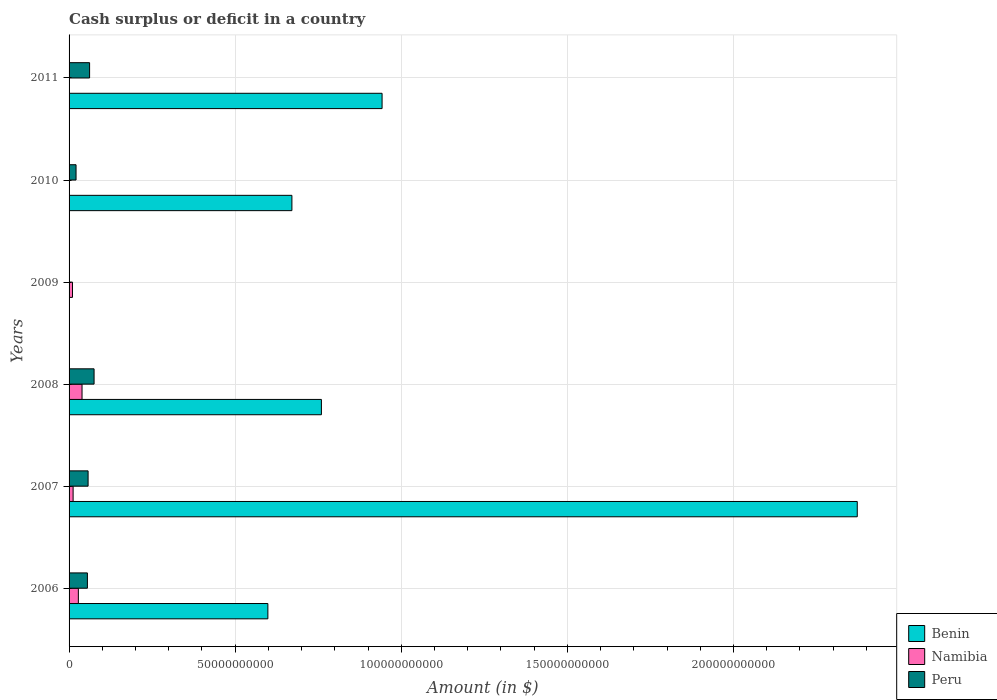Are the number of bars on each tick of the Y-axis equal?
Provide a succinct answer. No. In how many cases, is the number of bars for a given year not equal to the number of legend labels?
Offer a very short reply. 3. What is the amount of cash surplus or deficit in Benin in 2008?
Give a very brief answer. 7.60e+1. Across all years, what is the maximum amount of cash surplus or deficit in Peru?
Your answer should be compact. 7.53e+09. In which year was the amount of cash surplus or deficit in Benin maximum?
Give a very brief answer. 2007. What is the total amount of cash surplus or deficit in Namibia in the graph?
Keep it short and to the point. 8.94e+09. What is the difference between the amount of cash surplus or deficit in Peru in 2006 and that in 2007?
Offer a very short reply. -2.06e+08. What is the difference between the amount of cash surplus or deficit in Benin in 2009 and the amount of cash surplus or deficit in Peru in 2008?
Provide a short and direct response. -7.53e+09. What is the average amount of cash surplus or deficit in Namibia per year?
Make the answer very short. 1.49e+09. In the year 2006, what is the difference between the amount of cash surplus or deficit in Namibia and amount of cash surplus or deficit in Peru?
Your answer should be compact. -2.73e+09. In how many years, is the amount of cash surplus or deficit in Namibia greater than 40000000000 $?
Your answer should be very brief. 0. What is the ratio of the amount of cash surplus or deficit in Benin in 2007 to that in 2011?
Keep it short and to the point. 2.52. Is the amount of cash surplus or deficit in Peru in 2010 less than that in 2011?
Keep it short and to the point. Yes. What is the difference between the highest and the second highest amount of cash surplus or deficit in Benin?
Give a very brief answer. 1.43e+11. What is the difference between the highest and the lowest amount of cash surplus or deficit in Namibia?
Ensure brevity in your answer.  3.90e+09. How many bars are there?
Give a very brief answer. 14. Are all the bars in the graph horizontal?
Offer a terse response. Yes. How many years are there in the graph?
Your answer should be very brief. 6. Are the values on the major ticks of X-axis written in scientific E-notation?
Make the answer very short. No. Does the graph contain any zero values?
Your answer should be compact. Yes. What is the title of the graph?
Your answer should be very brief. Cash surplus or deficit in a country. Does "Pakistan" appear as one of the legend labels in the graph?
Offer a very short reply. No. What is the label or title of the X-axis?
Your answer should be very brief. Amount (in $). What is the Amount (in $) in Benin in 2006?
Keep it short and to the point. 5.98e+1. What is the Amount (in $) in Namibia in 2006?
Ensure brevity in your answer.  2.79e+09. What is the Amount (in $) of Peru in 2006?
Offer a very short reply. 5.52e+09. What is the Amount (in $) in Benin in 2007?
Provide a short and direct response. 2.37e+11. What is the Amount (in $) of Namibia in 2007?
Keep it short and to the point. 1.22e+09. What is the Amount (in $) of Peru in 2007?
Offer a very short reply. 5.73e+09. What is the Amount (in $) of Benin in 2008?
Your answer should be compact. 7.60e+1. What is the Amount (in $) in Namibia in 2008?
Keep it short and to the point. 3.90e+09. What is the Amount (in $) of Peru in 2008?
Provide a short and direct response. 7.53e+09. What is the Amount (in $) in Benin in 2009?
Your answer should be very brief. 0. What is the Amount (in $) of Namibia in 2009?
Ensure brevity in your answer.  1.03e+09. What is the Amount (in $) of Benin in 2010?
Your answer should be compact. 6.71e+1. What is the Amount (in $) in Namibia in 2010?
Ensure brevity in your answer.  0. What is the Amount (in $) of Peru in 2010?
Keep it short and to the point. 2.10e+09. What is the Amount (in $) of Benin in 2011?
Your answer should be compact. 9.42e+1. What is the Amount (in $) of Namibia in 2011?
Provide a short and direct response. 0. What is the Amount (in $) in Peru in 2011?
Offer a very short reply. 6.18e+09. Across all years, what is the maximum Amount (in $) of Benin?
Make the answer very short. 2.37e+11. Across all years, what is the maximum Amount (in $) of Namibia?
Your response must be concise. 3.90e+09. Across all years, what is the maximum Amount (in $) of Peru?
Keep it short and to the point. 7.53e+09. Across all years, what is the minimum Amount (in $) of Benin?
Keep it short and to the point. 0. Across all years, what is the minimum Amount (in $) of Peru?
Give a very brief answer. 0. What is the total Amount (in $) in Benin in the graph?
Offer a very short reply. 5.34e+11. What is the total Amount (in $) of Namibia in the graph?
Make the answer very short. 8.94e+09. What is the total Amount (in $) in Peru in the graph?
Your answer should be very brief. 2.71e+1. What is the difference between the Amount (in $) of Benin in 2006 and that in 2007?
Provide a succinct answer. -1.77e+11. What is the difference between the Amount (in $) of Namibia in 2006 and that in 2007?
Make the answer very short. 1.58e+09. What is the difference between the Amount (in $) of Peru in 2006 and that in 2007?
Ensure brevity in your answer.  -2.06e+08. What is the difference between the Amount (in $) in Benin in 2006 and that in 2008?
Provide a succinct answer. -1.61e+1. What is the difference between the Amount (in $) in Namibia in 2006 and that in 2008?
Keep it short and to the point. -1.11e+09. What is the difference between the Amount (in $) of Peru in 2006 and that in 2008?
Ensure brevity in your answer.  -2.01e+09. What is the difference between the Amount (in $) in Namibia in 2006 and that in 2009?
Give a very brief answer. 1.77e+09. What is the difference between the Amount (in $) of Benin in 2006 and that in 2010?
Ensure brevity in your answer.  -7.23e+09. What is the difference between the Amount (in $) in Peru in 2006 and that in 2010?
Offer a terse response. 3.42e+09. What is the difference between the Amount (in $) of Benin in 2006 and that in 2011?
Provide a short and direct response. -3.44e+1. What is the difference between the Amount (in $) of Peru in 2006 and that in 2011?
Provide a succinct answer. -6.57e+08. What is the difference between the Amount (in $) of Benin in 2007 and that in 2008?
Make the answer very short. 1.61e+11. What is the difference between the Amount (in $) of Namibia in 2007 and that in 2008?
Offer a very short reply. -2.69e+09. What is the difference between the Amount (in $) of Peru in 2007 and that in 2008?
Keep it short and to the point. -1.80e+09. What is the difference between the Amount (in $) in Namibia in 2007 and that in 2009?
Ensure brevity in your answer.  1.88e+08. What is the difference between the Amount (in $) of Benin in 2007 and that in 2010?
Give a very brief answer. 1.70e+11. What is the difference between the Amount (in $) in Peru in 2007 and that in 2010?
Provide a short and direct response. 3.63e+09. What is the difference between the Amount (in $) of Benin in 2007 and that in 2011?
Your answer should be compact. 1.43e+11. What is the difference between the Amount (in $) in Peru in 2007 and that in 2011?
Provide a succinct answer. -4.52e+08. What is the difference between the Amount (in $) in Namibia in 2008 and that in 2009?
Provide a succinct answer. 2.87e+09. What is the difference between the Amount (in $) of Benin in 2008 and that in 2010?
Offer a terse response. 8.88e+09. What is the difference between the Amount (in $) of Peru in 2008 and that in 2010?
Your response must be concise. 5.43e+09. What is the difference between the Amount (in $) in Benin in 2008 and that in 2011?
Offer a terse response. -1.83e+1. What is the difference between the Amount (in $) in Peru in 2008 and that in 2011?
Your answer should be compact. 1.35e+09. What is the difference between the Amount (in $) in Benin in 2010 and that in 2011?
Offer a terse response. -2.71e+1. What is the difference between the Amount (in $) in Peru in 2010 and that in 2011?
Offer a very short reply. -4.08e+09. What is the difference between the Amount (in $) of Benin in 2006 and the Amount (in $) of Namibia in 2007?
Keep it short and to the point. 5.86e+1. What is the difference between the Amount (in $) of Benin in 2006 and the Amount (in $) of Peru in 2007?
Your answer should be very brief. 5.41e+1. What is the difference between the Amount (in $) in Namibia in 2006 and the Amount (in $) in Peru in 2007?
Offer a terse response. -2.93e+09. What is the difference between the Amount (in $) in Benin in 2006 and the Amount (in $) in Namibia in 2008?
Your response must be concise. 5.59e+1. What is the difference between the Amount (in $) in Benin in 2006 and the Amount (in $) in Peru in 2008?
Keep it short and to the point. 5.23e+1. What is the difference between the Amount (in $) in Namibia in 2006 and the Amount (in $) in Peru in 2008?
Your answer should be compact. -4.73e+09. What is the difference between the Amount (in $) in Benin in 2006 and the Amount (in $) in Namibia in 2009?
Provide a short and direct response. 5.88e+1. What is the difference between the Amount (in $) in Benin in 2006 and the Amount (in $) in Peru in 2010?
Ensure brevity in your answer.  5.77e+1. What is the difference between the Amount (in $) of Namibia in 2006 and the Amount (in $) of Peru in 2010?
Your response must be concise. 6.94e+08. What is the difference between the Amount (in $) in Benin in 2006 and the Amount (in $) in Peru in 2011?
Make the answer very short. 5.37e+1. What is the difference between the Amount (in $) in Namibia in 2006 and the Amount (in $) in Peru in 2011?
Offer a terse response. -3.38e+09. What is the difference between the Amount (in $) of Benin in 2007 and the Amount (in $) of Namibia in 2008?
Keep it short and to the point. 2.33e+11. What is the difference between the Amount (in $) of Benin in 2007 and the Amount (in $) of Peru in 2008?
Make the answer very short. 2.30e+11. What is the difference between the Amount (in $) of Namibia in 2007 and the Amount (in $) of Peru in 2008?
Give a very brief answer. -6.31e+09. What is the difference between the Amount (in $) of Benin in 2007 and the Amount (in $) of Namibia in 2009?
Your answer should be compact. 2.36e+11. What is the difference between the Amount (in $) in Benin in 2007 and the Amount (in $) in Peru in 2010?
Ensure brevity in your answer.  2.35e+11. What is the difference between the Amount (in $) of Namibia in 2007 and the Amount (in $) of Peru in 2010?
Make the answer very short. -8.84e+08. What is the difference between the Amount (in $) of Benin in 2007 and the Amount (in $) of Peru in 2011?
Give a very brief answer. 2.31e+11. What is the difference between the Amount (in $) in Namibia in 2007 and the Amount (in $) in Peru in 2011?
Offer a very short reply. -4.96e+09. What is the difference between the Amount (in $) of Benin in 2008 and the Amount (in $) of Namibia in 2009?
Provide a short and direct response. 7.49e+1. What is the difference between the Amount (in $) of Benin in 2008 and the Amount (in $) of Peru in 2010?
Make the answer very short. 7.39e+1. What is the difference between the Amount (in $) of Namibia in 2008 and the Amount (in $) of Peru in 2010?
Provide a succinct answer. 1.80e+09. What is the difference between the Amount (in $) in Benin in 2008 and the Amount (in $) in Peru in 2011?
Your answer should be compact. 6.98e+1. What is the difference between the Amount (in $) of Namibia in 2008 and the Amount (in $) of Peru in 2011?
Offer a very short reply. -2.28e+09. What is the difference between the Amount (in $) in Namibia in 2009 and the Amount (in $) in Peru in 2010?
Ensure brevity in your answer.  -1.07e+09. What is the difference between the Amount (in $) in Namibia in 2009 and the Amount (in $) in Peru in 2011?
Give a very brief answer. -5.15e+09. What is the difference between the Amount (in $) of Benin in 2010 and the Amount (in $) of Peru in 2011?
Your response must be concise. 6.09e+1. What is the average Amount (in $) in Benin per year?
Your response must be concise. 8.91e+1. What is the average Amount (in $) in Namibia per year?
Offer a very short reply. 1.49e+09. What is the average Amount (in $) of Peru per year?
Provide a short and direct response. 4.51e+09. In the year 2006, what is the difference between the Amount (in $) of Benin and Amount (in $) of Namibia?
Offer a very short reply. 5.71e+1. In the year 2006, what is the difference between the Amount (in $) of Benin and Amount (in $) of Peru?
Offer a very short reply. 5.43e+1. In the year 2006, what is the difference between the Amount (in $) of Namibia and Amount (in $) of Peru?
Offer a terse response. -2.73e+09. In the year 2007, what is the difference between the Amount (in $) in Benin and Amount (in $) in Namibia?
Give a very brief answer. 2.36e+11. In the year 2007, what is the difference between the Amount (in $) of Benin and Amount (in $) of Peru?
Your answer should be very brief. 2.32e+11. In the year 2007, what is the difference between the Amount (in $) in Namibia and Amount (in $) in Peru?
Keep it short and to the point. -4.51e+09. In the year 2008, what is the difference between the Amount (in $) in Benin and Amount (in $) in Namibia?
Provide a short and direct response. 7.21e+1. In the year 2008, what is the difference between the Amount (in $) of Benin and Amount (in $) of Peru?
Offer a terse response. 6.84e+1. In the year 2008, what is the difference between the Amount (in $) in Namibia and Amount (in $) in Peru?
Your answer should be compact. -3.62e+09. In the year 2010, what is the difference between the Amount (in $) of Benin and Amount (in $) of Peru?
Keep it short and to the point. 6.50e+1. In the year 2011, what is the difference between the Amount (in $) of Benin and Amount (in $) of Peru?
Your answer should be very brief. 8.80e+1. What is the ratio of the Amount (in $) of Benin in 2006 to that in 2007?
Your response must be concise. 0.25. What is the ratio of the Amount (in $) of Namibia in 2006 to that in 2007?
Keep it short and to the point. 2.3. What is the ratio of the Amount (in $) in Benin in 2006 to that in 2008?
Give a very brief answer. 0.79. What is the ratio of the Amount (in $) of Namibia in 2006 to that in 2008?
Give a very brief answer. 0.72. What is the ratio of the Amount (in $) of Peru in 2006 to that in 2008?
Your response must be concise. 0.73. What is the ratio of the Amount (in $) of Namibia in 2006 to that in 2009?
Provide a short and direct response. 2.72. What is the ratio of the Amount (in $) in Benin in 2006 to that in 2010?
Provide a succinct answer. 0.89. What is the ratio of the Amount (in $) of Peru in 2006 to that in 2010?
Your answer should be compact. 2.63. What is the ratio of the Amount (in $) in Benin in 2006 to that in 2011?
Provide a succinct answer. 0.64. What is the ratio of the Amount (in $) in Peru in 2006 to that in 2011?
Offer a terse response. 0.89. What is the ratio of the Amount (in $) in Benin in 2007 to that in 2008?
Your response must be concise. 3.12. What is the ratio of the Amount (in $) of Namibia in 2007 to that in 2008?
Offer a very short reply. 0.31. What is the ratio of the Amount (in $) in Peru in 2007 to that in 2008?
Give a very brief answer. 0.76. What is the ratio of the Amount (in $) of Namibia in 2007 to that in 2009?
Keep it short and to the point. 1.18. What is the ratio of the Amount (in $) in Benin in 2007 to that in 2010?
Provide a succinct answer. 3.54. What is the ratio of the Amount (in $) of Peru in 2007 to that in 2010?
Offer a very short reply. 2.73. What is the ratio of the Amount (in $) in Benin in 2007 to that in 2011?
Your answer should be compact. 2.52. What is the ratio of the Amount (in $) in Peru in 2007 to that in 2011?
Give a very brief answer. 0.93. What is the ratio of the Amount (in $) in Namibia in 2008 to that in 2009?
Provide a short and direct response. 3.79. What is the ratio of the Amount (in $) of Benin in 2008 to that in 2010?
Ensure brevity in your answer.  1.13. What is the ratio of the Amount (in $) of Peru in 2008 to that in 2010?
Give a very brief answer. 3.58. What is the ratio of the Amount (in $) in Benin in 2008 to that in 2011?
Give a very brief answer. 0.81. What is the ratio of the Amount (in $) in Peru in 2008 to that in 2011?
Offer a very short reply. 1.22. What is the ratio of the Amount (in $) of Benin in 2010 to that in 2011?
Give a very brief answer. 0.71. What is the ratio of the Amount (in $) in Peru in 2010 to that in 2011?
Provide a short and direct response. 0.34. What is the difference between the highest and the second highest Amount (in $) in Benin?
Your answer should be compact. 1.43e+11. What is the difference between the highest and the second highest Amount (in $) in Namibia?
Your answer should be very brief. 1.11e+09. What is the difference between the highest and the second highest Amount (in $) in Peru?
Your answer should be very brief. 1.35e+09. What is the difference between the highest and the lowest Amount (in $) in Benin?
Keep it short and to the point. 2.37e+11. What is the difference between the highest and the lowest Amount (in $) of Namibia?
Provide a short and direct response. 3.90e+09. What is the difference between the highest and the lowest Amount (in $) of Peru?
Make the answer very short. 7.53e+09. 